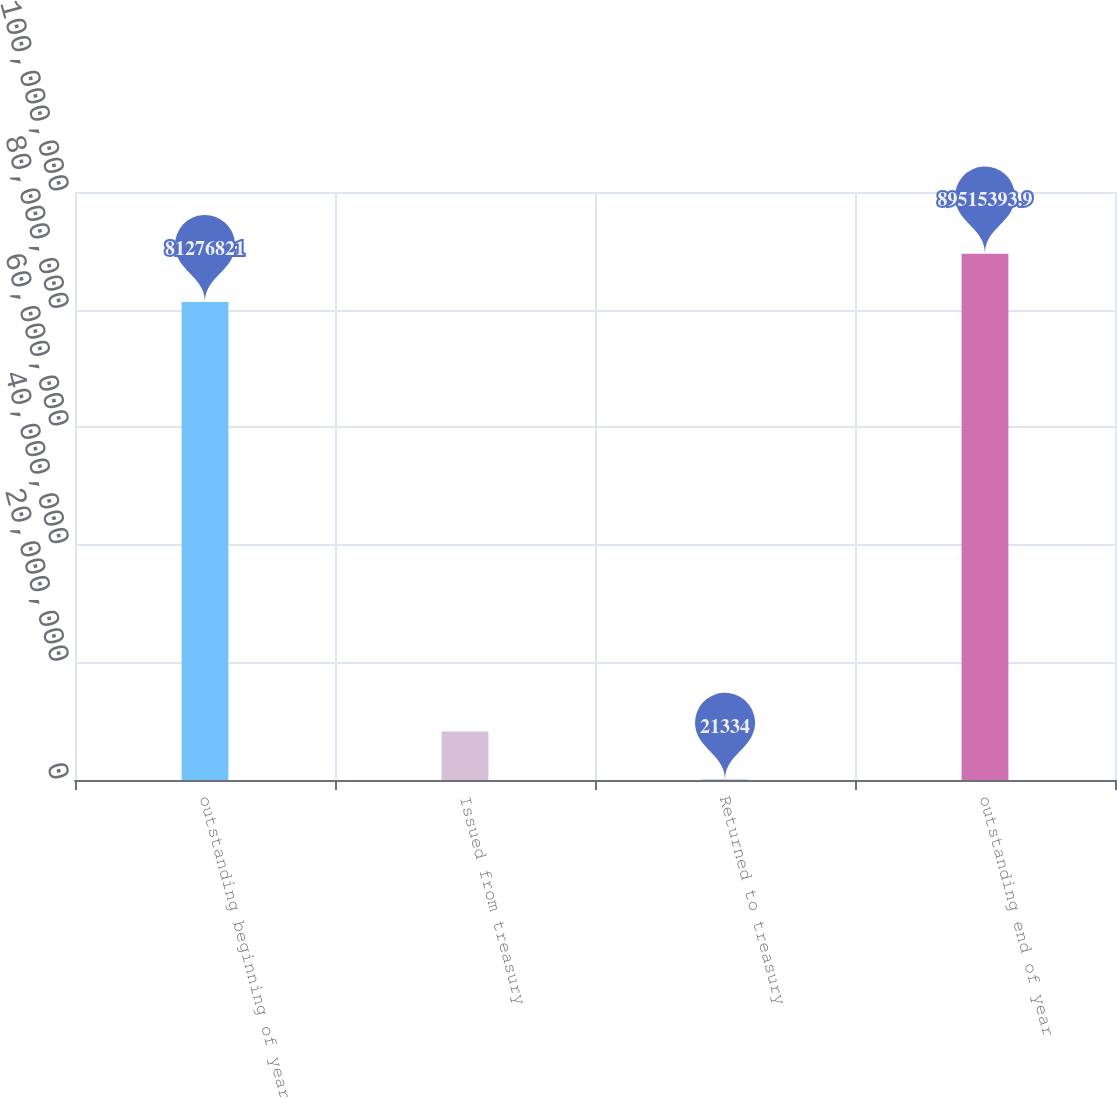<chart> <loc_0><loc_0><loc_500><loc_500><bar_chart><fcel>outstanding beginning of year<fcel>Issued from treasury<fcel>Returned to treasury<fcel>outstanding end of year<nl><fcel>8.12768e+07<fcel>8.25991e+06<fcel>21334<fcel>8.95154e+07<nl></chart> 